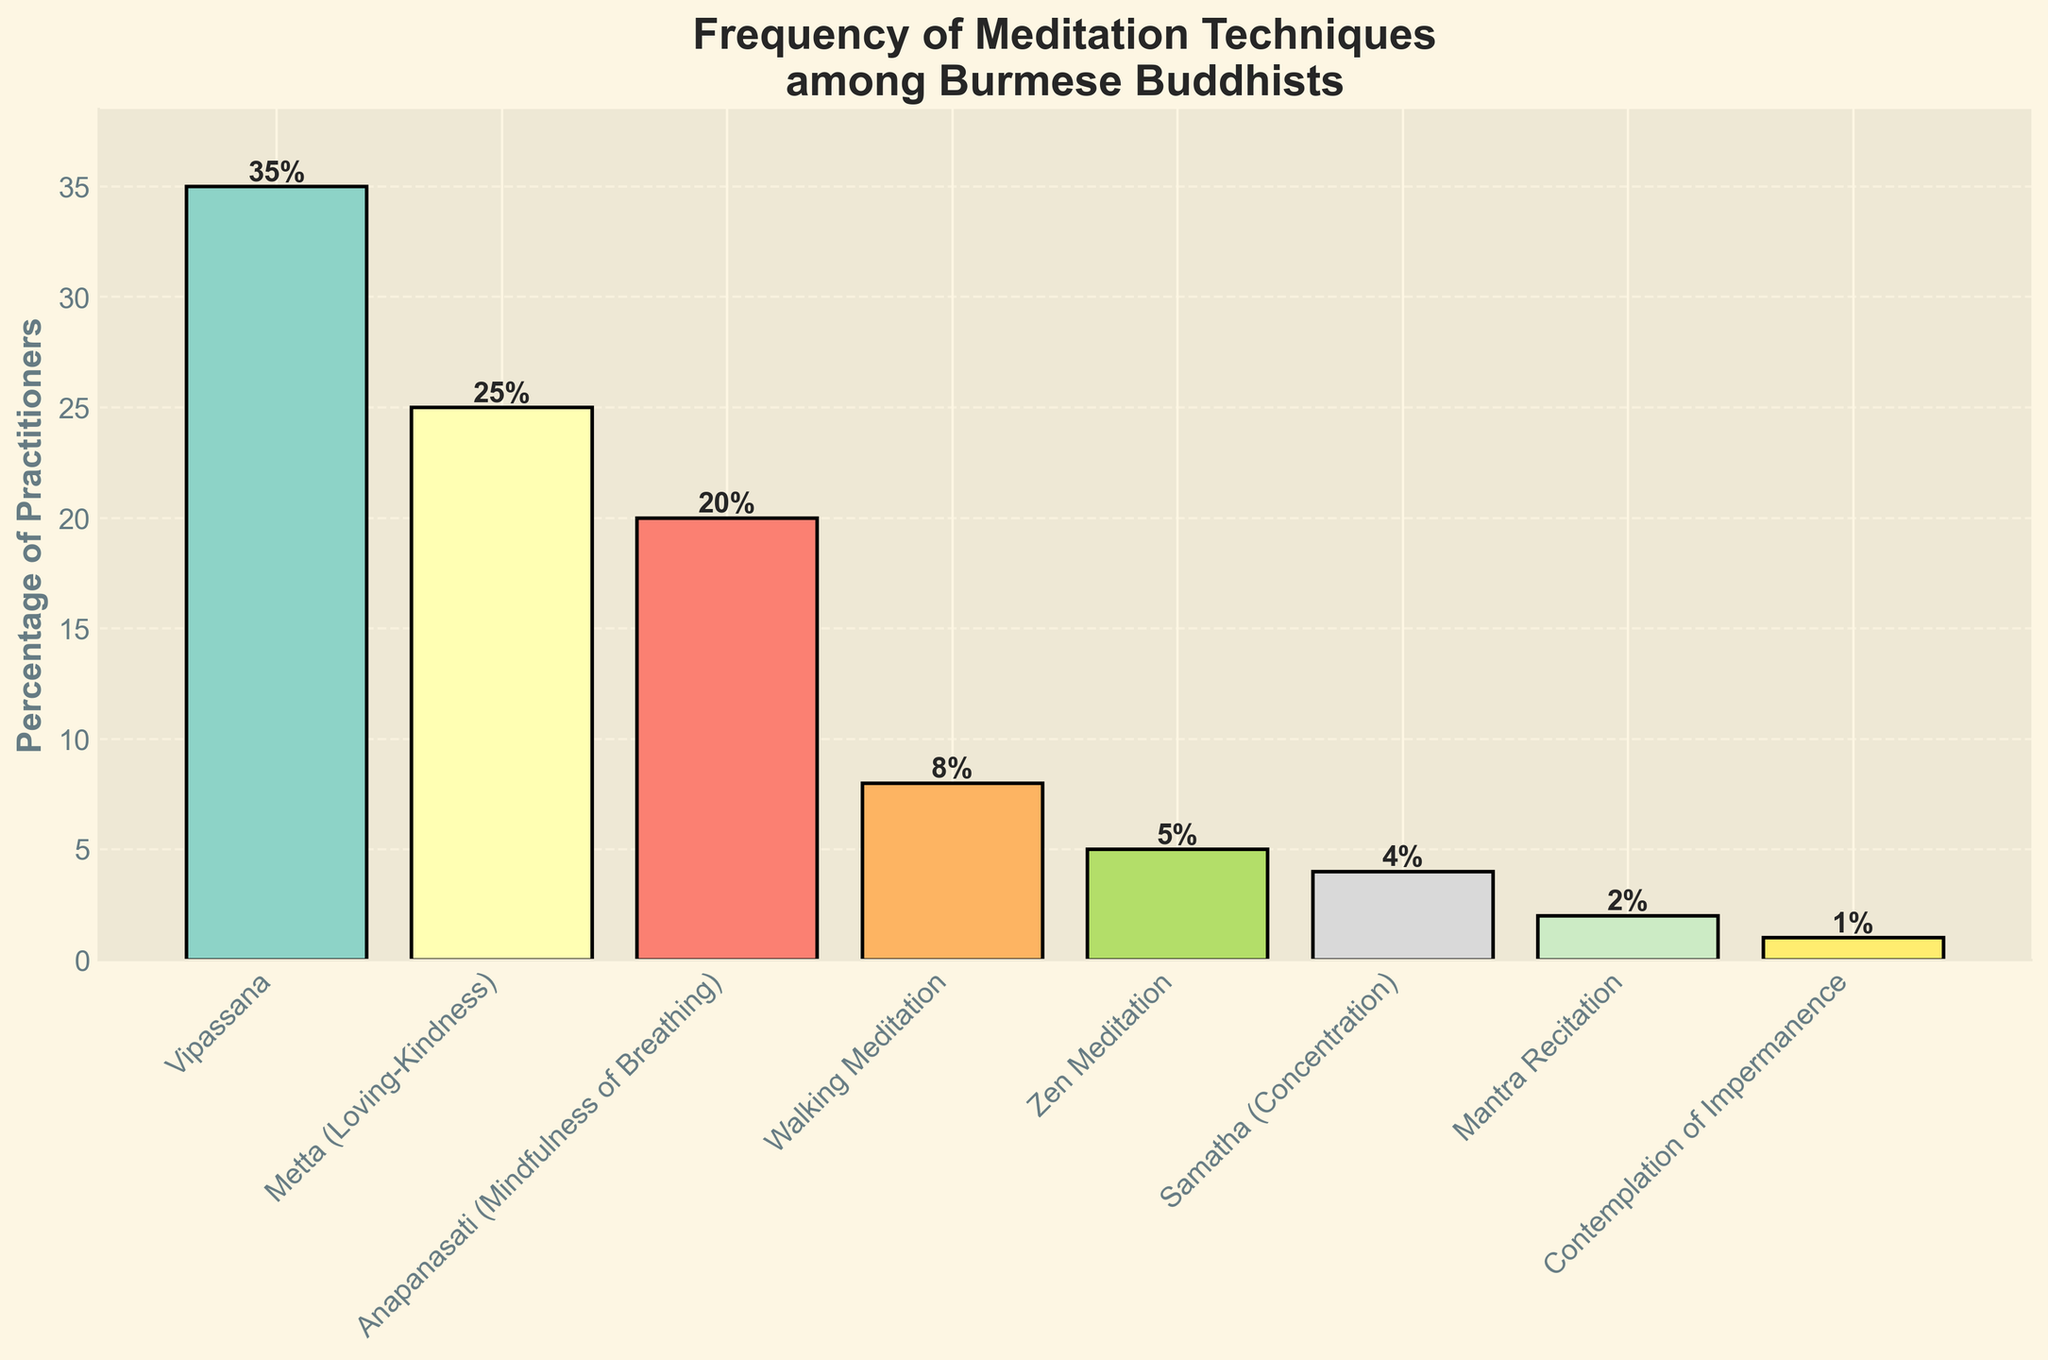Which meditation technique has the highest percentage of practitioners? Observe the heights of the bars. The tallest bar represents Vipassana with 35%.
Answer: Vipassana What is the total percentage of practitioners for Anapanasati and Metta combined? Add the percentages of Anapanasati (20%) and Metta (25%). The total is 20 + 25 = 45%.
Answer: 45% Which meditation techniques have a percentage of practitioners less than 10%? Look for bars lower than the 10% line. These techniques are Walking Meditation (8%), Zen Meditation (5%), Samatha (4%), Mantra Recitation (2%), and Contemplation of Impermanence (1%).
Answer: Walking Meditation, Zen Meditation, Samatha, Mantra Recitation, Contemplation of Impermanence How much more popular is Vipassana compared to Zen Meditation in percentage points? Subtract the percentage of Zen Meditation (5%) from the percentage of Vipassana (35%). The difference is 35 - 5 = 30%.
Answer: 30% What percentage of practitioners practice techniques other than Vipassana, Metta, and Anapanasati? Sum the percentages of techniques excluding Vipassana, Metta, and Anapanasati: Walking Meditation (8%) + Zen Meditation (5%) + Samatha (4%) + Mantra Recitation (2%) + Contemplation of Impermanence (1%) = 8 + 5 + 4 + 2 + 1 = 20%.
Answer: 20% Which technique is practiced more, Zen Meditation or Walking Meditation, and by how much? Compare the heights of the bars for Zen Meditation (5%) and Walking Meditation (8%). The difference is 8 - 5 = 3%.
Answer: Walking Meditation by 3% What is the average percentage of practitioners for all techniques? Sum all the percentages: 35 + 25 + 20 + 8 + 5 + 4 + 2 + 1 = 100%. Divide by the number of techniques (8). The average is 100 / 8 = 12.5%.
Answer: 12.5% If the percentage of Vipassana practitioners increased by 10%, what would the new total be? Add 10% to the current percentage of Vipassana (35%). The new percentage is 35 + 10 = 45%.
Answer: 45% What is the difference in popularity between the most and least practiced techniques? Subtract the least practiced technique (Contemplation of Impermanence, 1%) from the most practiced technique (Vipassana, 35%). The difference is 35 - 1 = 34%.
Answer: 34% Order the meditation techniques from the least to the most practiced. Ascending order of percentages: Contemplation of Impermanence (1%), Mantra Recitation (2%), Samatha (4%), Zen Meditation (5%), Walking Meditation (8%), Anapanasati (20%), Metta (25%), Vipassana (35%).
Answer: Contemplation of Impermanence, Mantra Recitation, Samatha, Zen Meditation, Walking Meditation, Anapanasati, Metta, Vipassana 